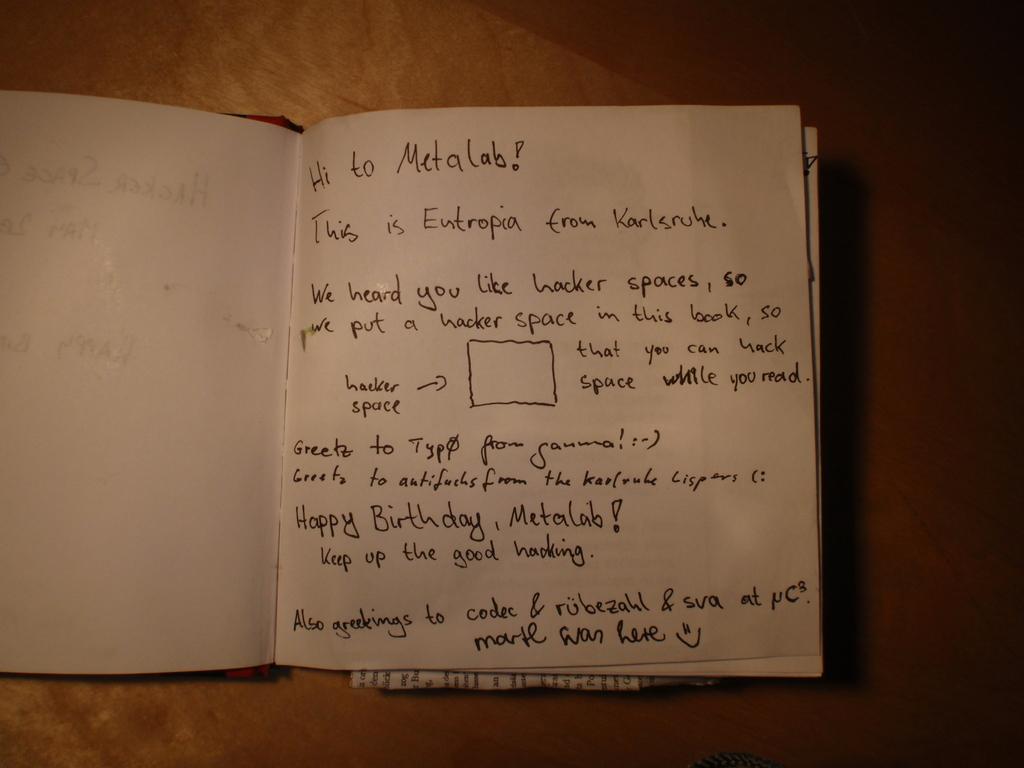Whose birthday is it?
Provide a succinct answer. Metalab. 